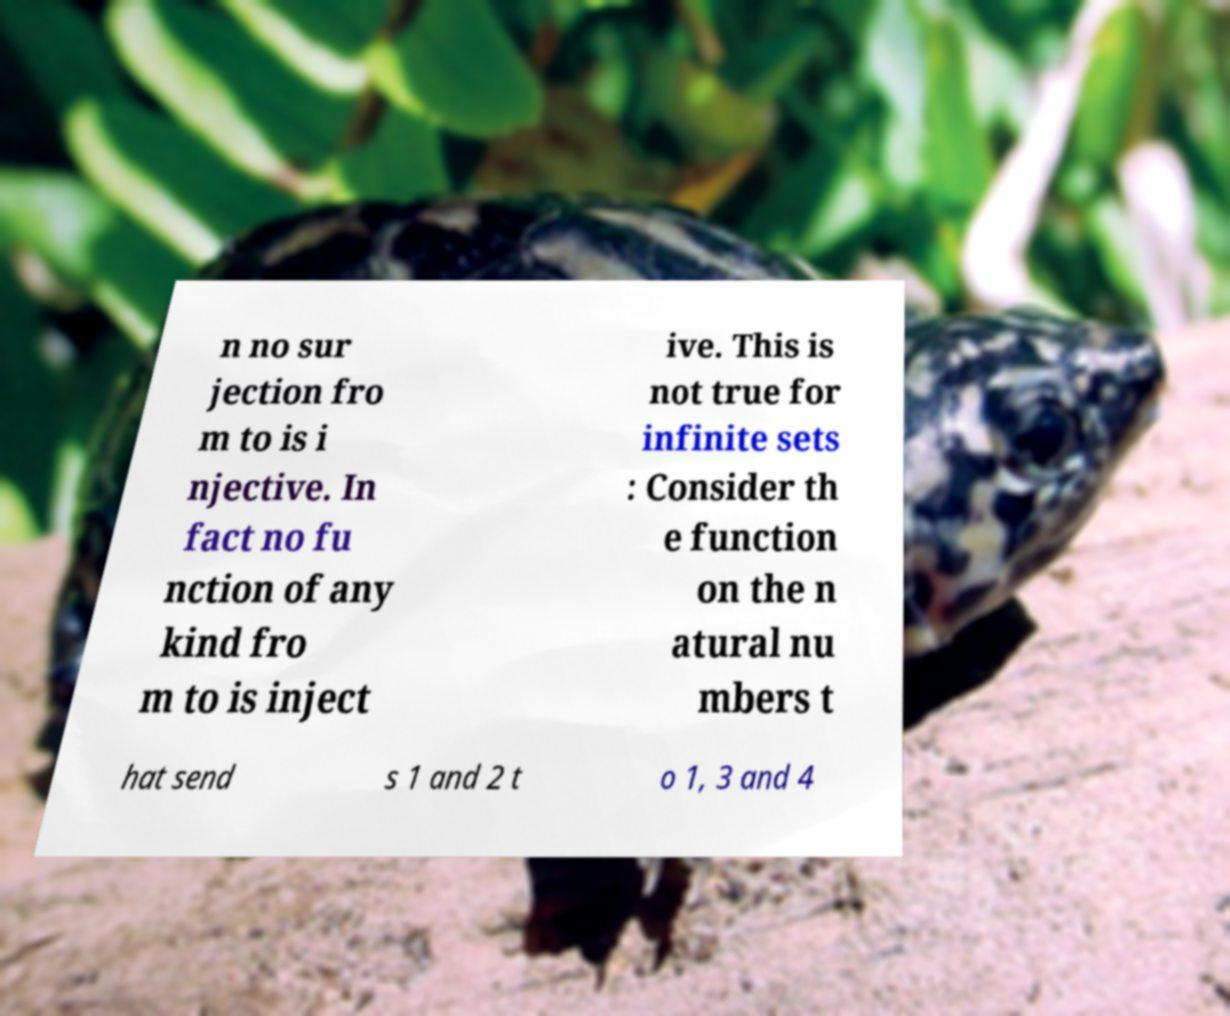Could you assist in decoding the text presented in this image and type it out clearly? n no sur jection fro m to is i njective. In fact no fu nction of any kind fro m to is inject ive. This is not true for infinite sets : Consider th e function on the n atural nu mbers t hat send s 1 and 2 t o 1, 3 and 4 